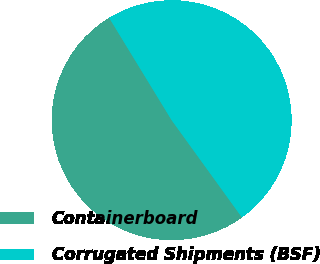Convert chart to OTSL. <chart><loc_0><loc_0><loc_500><loc_500><pie_chart><fcel>Containerboard<fcel>Corrugated Shipments (BSF)<nl><fcel>51.24%<fcel>48.76%<nl></chart> 